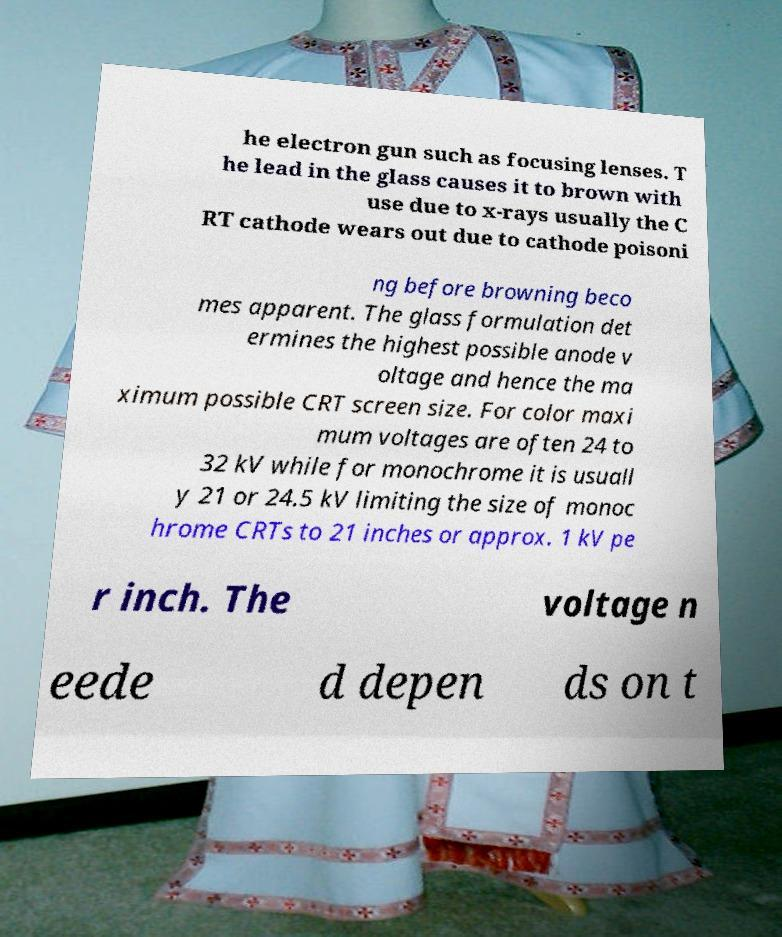Please identify and transcribe the text found in this image. he electron gun such as focusing lenses. T he lead in the glass causes it to brown with use due to x-rays usually the C RT cathode wears out due to cathode poisoni ng before browning beco mes apparent. The glass formulation det ermines the highest possible anode v oltage and hence the ma ximum possible CRT screen size. For color maxi mum voltages are often 24 to 32 kV while for monochrome it is usuall y 21 or 24.5 kV limiting the size of monoc hrome CRTs to 21 inches or approx. 1 kV pe r inch. The voltage n eede d depen ds on t 